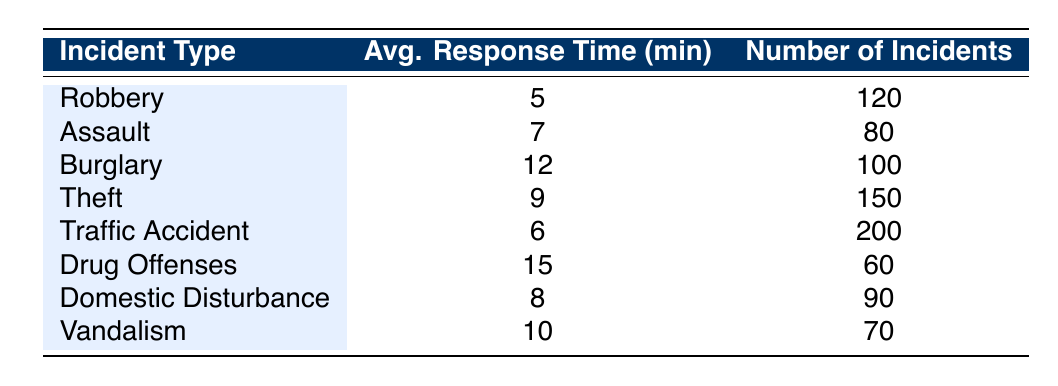What is the average response time for Theft incidents? The table shows that average response time for Theft is listed as 9 minutes.
Answer: 9 Which incident type has the longest average response time? By comparing the average response times, Drug Offenses has the longest average response time of 15 minutes.
Answer: Drug Offenses How many total incidents are covered in the table? To calculate the total incidents, sum up the number of incidents: 120 + 80 + 100 + 150 + 200 + 60 + 90 + 70 = 870.
Answer: 870 Is the average response time for Domestic Disturbance less than 10 minutes? The average response time for Domestic Disturbance is 8 minutes, which is indeed less than 10 minutes.
Answer: Yes What is the average response time for all incidents listed in the table? To find the average, first calculate the sum of all average response times: 5 + 7 + 12 + 9 + 6 + 15 + 8 + 10 = 72. There are 8 incidents, so the average response time is 72 / 8 = 9 minutes.
Answer: 9 Which incident types have an average response time greater than 8 minutes? By reviewing the table, the incident types with an average response time greater than 8 minutes are Burglary (12), Theft (9), Drug Offenses (15), and Vandalism (10).
Answer: Burglary, Theft, Drug Offenses, Vandalism What is the difference in average response time between the quickest and the slowest incident types? The quickest average response time is for Robbery at 5 minutes, and the slowest is for Drug Offenses at 15 minutes. The difference is 15 - 5 = 10 minutes.
Answer: 10 Are there more incidents related to Traffic Accidents than Drug Offenses? The table indicates there are 200 Traffic Accident incidents and 60 Drug Offenses incidents, so yes, there are more incidents related to Traffic Accidents.
Answer: Yes What is the average number of incidents per type? To find this, sum all the incidents: 870 (from a previous calculation) and divide by the number of types (8). Therefore, the average is 870 / 8 = 108.75 incidents per type.
Answer: 108.75 